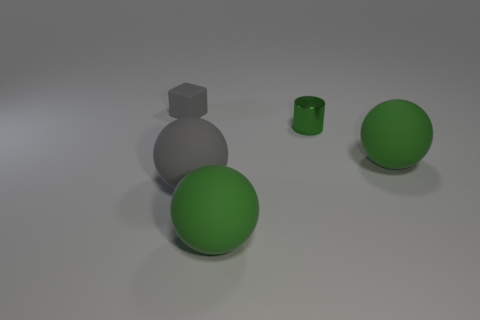Subtract all gray matte balls. How many balls are left? 2 Add 4 big gray matte spheres. How many objects exist? 9 Subtract all cubes. How many objects are left? 4 Add 4 tiny rubber objects. How many tiny rubber objects exist? 5 Subtract 1 gray spheres. How many objects are left? 4 Subtract all green rubber objects. Subtract all gray matte spheres. How many objects are left? 2 Add 4 gray rubber spheres. How many gray rubber spheres are left? 5 